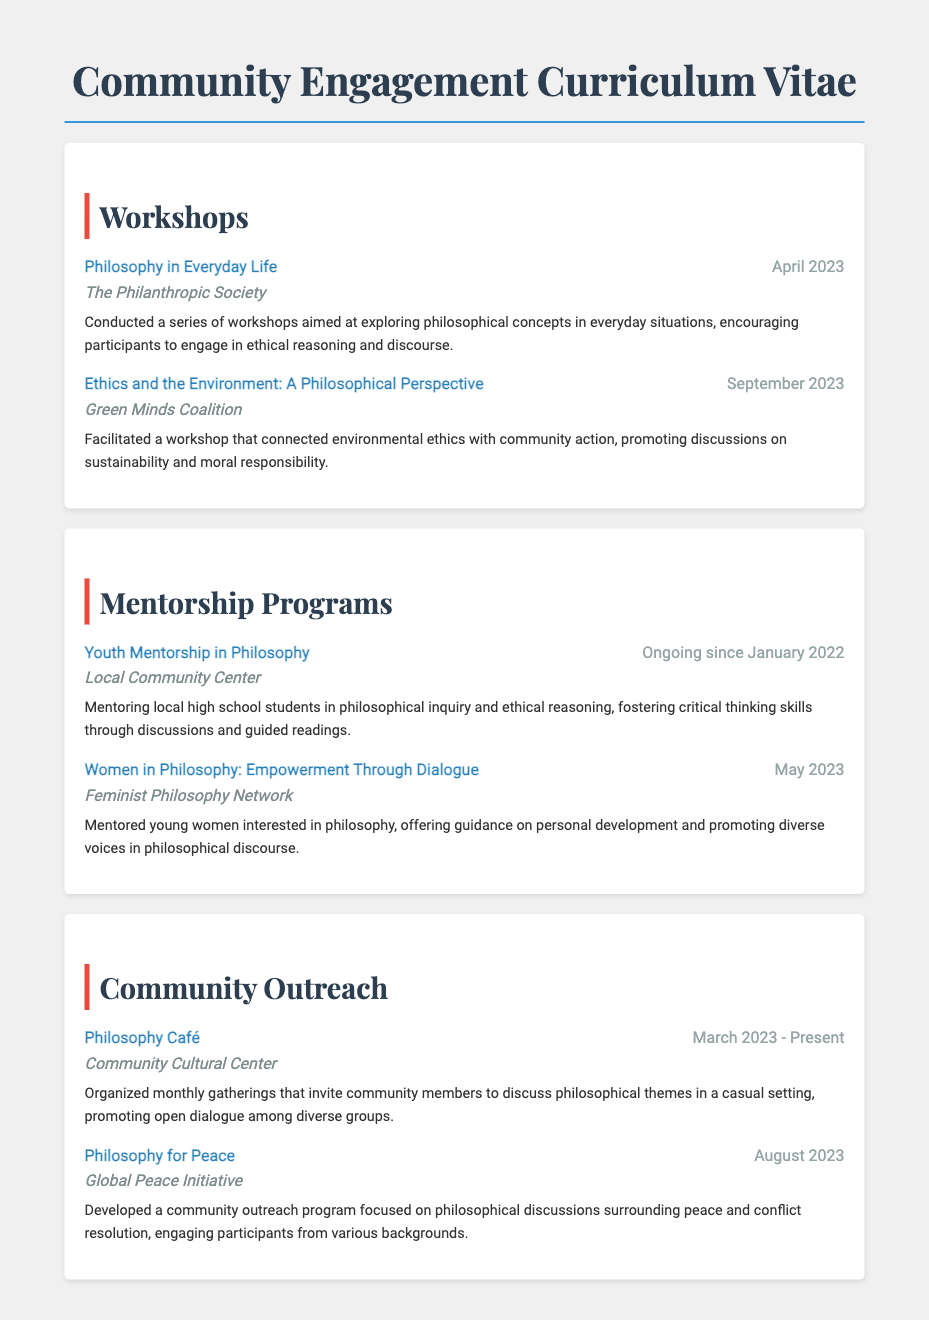what is the title of the first workshop listed? The title can be found at the beginning of the first item under the Workshops section.
Answer: Philosophy in Everyday Life what organization facilitated the workshop "Ethics and the Environment: A Philosophical Perspective"? This information is found in the item description where the organization is mentioned.
Answer: Green Minds Coalition when did the Youth Mentorship in Philosophy program start? The start date is specifically mentioned in the item description under the Mentorship Programs section.
Answer: Ongoing since January 2022 what type of event is the Philosophy Café? The nature of this event is described in the section about Community Outreach.
Answer: Gathering which organization is involved in the "Women in Philosophy: Empowerment Through Dialogue" mentorship program? The relevant organization is specified in the item description for this mentorship program.
Answer: Feminist Philosophy Network how often are Philosophy Café events held? The frequency of the gatherings is described in the Community Outreach section.
Answer: Monthly what topic does the "Philosophy for Peace" outreach program focus on? This information is conveyed in the item description under Community Outreach.
Answer: Peace and conflict resolution which workshop was held in September 2023? The month and year can be found in the item date of the relevant workshop.
Answer: Ethics and the Environment: A Philosophical Perspective 